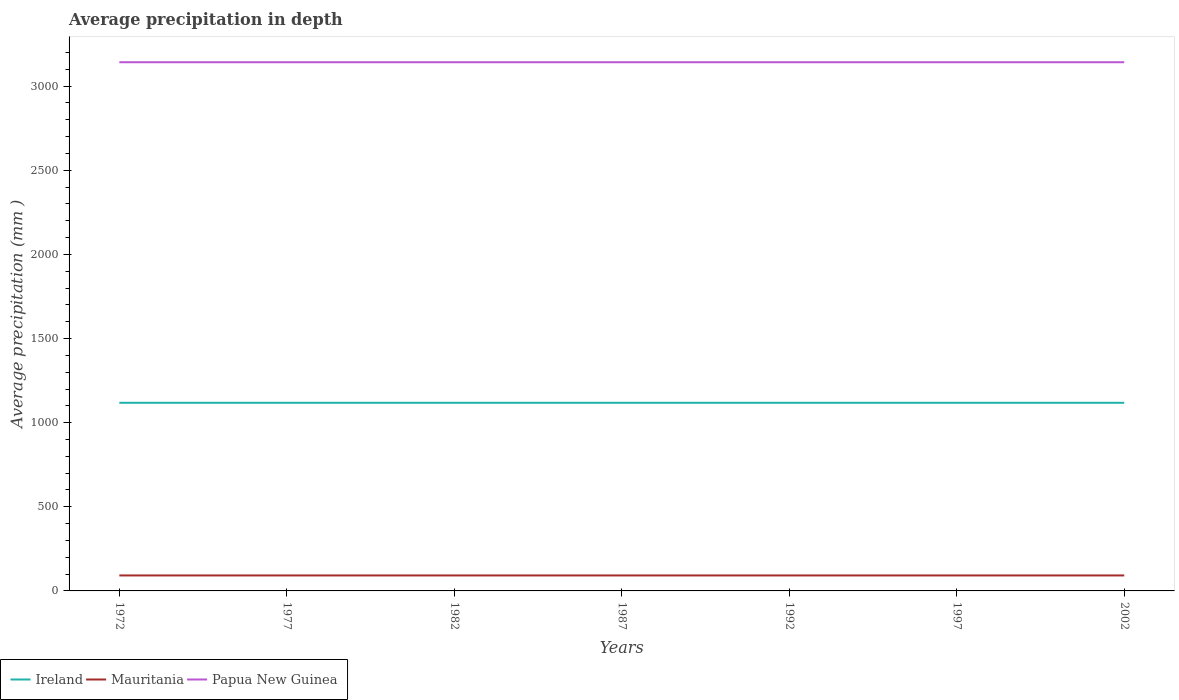How many different coloured lines are there?
Make the answer very short. 3. Does the line corresponding to Papua New Guinea intersect with the line corresponding to Ireland?
Make the answer very short. No. Is the number of lines equal to the number of legend labels?
Your answer should be compact. Yes. Across all years, what is the maximum average precipitation in Ireland?
Keep it short and to the point. 1118. In which year was the average precipitation in Ireland maximum?
Your answer should be compact. 1972. What is the total average precipitation in Mauritania in the graph?
Offer a terse response. 0. What is the difference between the highest and the second highest average precipitation in Ireland?
Offer a very short reply. 0. Is the average precipitation in Mauritania strictly greater than the average precipitation in Papua New Guinea over the years?
Provide a short and direct response. Yes. How many years are there in the graph?
Provide a succinct answer. 7. What is the difference between two consecutive major ticks on the Y-axis?
Provide a succinct answer. 500. Are the values on the major ticks of Y-axis written in scientific E-notation?
Offer a very short reply. No. Does the graph contain any zero values?
Your answer should be compact. No. Does the graph contain grids?
Your answer should be very brief. No. What is the title of the graph?
Provide a succinct answer. Average precipitation in depth. What is the label or title of the X-axis?
Offer a very short reply. Years. What is the label or title of the Y-axis?
Give a very brief answer. Average precipitation (mm ). What is the Average precipitation (mm ) in Ireland in 1972?
Your answer should be very brief. 1118. What is the Average precipitation (mm ) of Mauritania in 1972?
Give a very brief answer. 92. What is the Average precipitation (mm ) of Papua New Guinea in 1972?
Offer a terse response. 3142. What is the Average precipitation (mm ) of Ireland in 1977?
Your answer should be compact. 1118. What is the Average precipitation (mm ) in Mauritania in 1977?
Your response must be concise. 92. What is the Average precipitation (mm ) in Papua New Guinea in 1977?
Ensure brevity in your answer.  3142. What is the Average precipitation (mm ) of Ireland in 1982?
Ensure brevity in your answer.  1118. What is the Average precipitation (mm ) of Mauritania in 1982?
Make the answer very short. 92. What is the Average precipitation (mm ) in Papua New Guinea in 1982?
Your response must be concise. 3142. What is the Average precipitation (mm ) of Ireland in 1987?
Give a very brief answer. 1118. What is the Average precipitation (mm ) of Mauritania in 1987?
Your answer should be very brief. 92. What is the Average precipitation (mm ) of Papua New Guinea in 1987?
Make the answer very short. 3142. What is the Average precipitation (mm ) in Ireland in 1992?
Keep it short and to the point. 1118. What is the Average precipitation (mm ) in Mauritania in 1992?
Ensure brevity in your answer.  92. What is the Average precipitation (mm ) of Papua New Guinea in 1992?
Keep it short and to the point. 3142. What is the Average precipitation (mm ) of Ireland in 1997?
Give a very brief answer. 1118. What is the Average precipitation (mm ) in Mauritania in 1997?
Provide a short and direct response. 92. What is the Average precipitation (mm ) of Papua New Guinea in 1997?
Provide a succinct answer. 3142. What is the Average precipitation (mm ) of Ireland in 2002?
Your response must be concise. 1118. What is the Average precipitation (mm ) in Mauritania in 2002?
Keep it short and to the point. 92. What is the Average precipitation (mm ) of Papua New Guinea in 2002?
Provide a short and direct response. 3142. Across all years, what is the maximum Average precipitation (mm ) of Ireland?
Provide a short and direct response. 1118. Across all years, what is the maximum Average precipitation (mm ) in Mauritania?
Your answer should be very brief. 92. Across all years, what is the maximum Average precipitation (mm ) of Papua New Guinea?
Your answer should be compact. 3142. Across all years, what is the minimum Average precipitation (mm ) of Ireland?
Give a very brief answer. 1118. Across all years, what is the minimum Average precipitation (mm ) of Mauritania?
Make the answer very short. 92. Across all years, what is the minimum Average precipitation (mm ) in Papua New Guinea?
Your response must be concise. 3142. What is the total Average precipitation (mm ) of Ireland in the graph?
Offer a terse response. 7826. What is the total Average precipitation (mm ) of Mauritania in the graph?
Make the answer very short. 644. What is the total Average precipitation (mm ) in Papua New Guinea in the graph?
Provide a short and direct response. 2.20e+04. What is the difference between the Average precipitation (mm ) of Papua New Guinea in 1972 and that in 1977?
Keep it short and to the point. 0. What is the difference between the Average precipitation (mm ) of Papua New Guinea in 1972 and that in 1982?
Your answer should be compact. 0. What is the difference between the Average precipitation (mm ) in Ireland in 1972 and that in 2002?
Provide a short and direct response. 0. What is the difference between the Average precipitation (mm ) of Ireland in 1977 and that in 1982?
Give a very brief answer. 0. What is the difference between the Average precipitation (mm ) in Papua New Guinea in 1977 and that in 1982?
Offer a very short reply. 0. What is the difference between the Average precipitation (mm ) in Mauritania in 1977 and that in 1987?
Ensure brevity in your answer.  0. What is the difference between the Average precipitation (mm ) in Papua New Guinea in 1977 and that in 1987?
Give a very brief answer. 0. What is the difference between the Average precipitation (mm ) in Papua New Guinea in 1977 and that in 1992?
Your response must be concise. 0. What is the difference between the Average precipitation (mm ) in Papua New Guinea in 1977 and that in 1997?
Provide a succinct answer. 0. What is the difference between the Average precipitation (mm ) of Mauritania in 1982 and that in 1987?
Offer a very short reply. 0. What is the difference between the Average precipitation (mm ) in Ireland in 1982 and that in 1992?
Provide a succinct answer. 0. What is the difference between the Average precipitation (mm ) in Papua New Guinea in 1982 and that in 1992?
Give a very brief answer. 0. What is the difference between the Average precipitation (mm ) of Mauritania in 1982 and that in 1997?
Your answer should be very brief. 0. What is the difference between the Average precipitation (mm ) of Ireland in 1982 and that in 2002?
Your answer should be compact. 0. What is the difference between the Average precipitation (mm ) of Papua New Guinea in 1982 and that in 2002?
Make the answer very short. 0. What is the difference between the Average precipitation (mm ) of Ireland in 1987 and that in 1992?
Ensure brevity in your answer.  0. What is the difference between the Average precipitation (mm ) in Papua New Guinea in 1987 and that in 1997?
Your response must be concise. 0. What is the difference between the Average precipitation (mm ) of Ireland in 1987 and that in 2002?
Your answer should be compact. 0. What is the difference between the Average precipitation (mm ) of Ireland in 1992 and that in 1997?
Your answer should be very brief. 0. What is the difference between the Average precipitation (mm ) in Papua New Guinea in 1992 and that in 1997?
Offer a very short reply. 0. What is the difference between the Average precipitation (mm ) in Ireland in 1992 and that in 2002?
Make the answer very short. 0. What is the difference between the Average precipitation (mm ) in Mauritania in 1992 and that in 2002?
Provide a succinct answer. 0. What is the difference between the Average precipitation (mm ) in Mauritania in 1997 and that in 2002?
Keep it short and to the point. 0. What is the difference between the Average precipitation (mm ) in Papua New Guinea in 1997 and that in 2002?
Offer a terse response. 0. What is the difference between the Average precipitation (mm ) in Ireland in 1972 and the Average precipitation (mm ) in Mauritania in 1977?
Offer a terse response. 1026. What is the difference between the Average precipitation (mm ) of Ireland in 1972 and the Average precipitation (mm ) of Papua New Guinea in 1977?
Offer a very short reply. -2024. What is the difference between the Average precipitation (mm ) in Mauritania in 1972 and the Average precipitation (mm ) in Papua New Guinea in 1977?
Offer a terse response. -3050. What is the difference between the Average precipitation (mm ) of Ireland in 1972 and the Average precipitation (mm ) of Mauritania in 1982?
Keep it short and to the point. 1026. What is the difference between the Average precipitation (mm ) of Ireland in 1972 and the Average precipitation (mm ) of Papua New Guinea in 1982?
Give a very brief answer. -2024. What is the difference between the Average precipitation (mm ) in Mauritania in 1972 and the Average precipitation (mm ) in Papua New Guinea in 1982?
Your answer should be compact. -3050. What is the difference between the Average precipitation (mm ) in Ireland in 1972 and the Average precipitation (mm ) in Mauritania in 1987?
Offer a terse response. 1026. What is the difference between the Average precipitation (mm ) of Ireland in 1972 and the Average precipitation (mm ) of Papua New Guinea in 1987?
Offer a very short reply. -2024. What is the difference between the Average precipitation (mm ) of Mauritania in 1972 and the Average precipitation (mm ) of Papua New Guinea in 1987?
Provide a short and direct response. -3050. What is the difference between the Average precipitation (mm ) of Ireland in 1972 and the Average precipitation (mm ) of Mauritania in 1992?
Keep it short and to the point. 1026. What is the difference between the Average precipitation (mm ) of Ireland in 1972 and the Average precipitation (mm ) of Papua New Guinea in 1992?
Keep it short and to the point. -2024. What is the difference between the Average precipitation (mm ) of Mauritania in 1972 and the Average precipitation (mm ) of Papua New Guinea in 1992?
Keep it short and to the point. -3050. What is the difference between the Average precipitation (mm ) in Ireland in 1972 and the Average precipitation (mm ) in Mauritania in 1997?
Your response must be concise. 1026. What is the difference between the Average precipitation (mm ) of Ireland in 1972 and the Average precipitation (mm ) of Papua New Guinea in 1997?
Ensure brevity in your answer.  -2024. What is the difference between the Average precipitation (mm ) of Mauritania in 1972 and the Average precipitation (mm ) of Papua New Guinea in 1997?
Provide a short and direct response. -3050. What is the difference between the Average precipitation (mm ) of Ireland in 1972 and the Average precipitation (mm ) of Mauritania in 2002?
Offer a very short reply. 1026. What is the difference between the Average precipitation (mm ) of Ireland in 1972 and the Average precipitation (mm ) of Papua New Guinea in 2002?
Ensure brevity in your answer.  -2024. What is the difference between the Average precipitation (mm ) of Mauritania in 1972 and the Average precipitation (mm ) of Papua New Guinea in 2002?
Give a very brief answer. -3050. What is the difference between the Average precipitation (mm ) in Ireland in 1977 and the Average precipitation (mm ) in Mauritania in 1982?
Provide a short and direct response. 1026. What is the difference between the Average precipitation (mm ) of Ireland in 1977 and the Average precipitation (mm ) of Papua New Guinea in 1982?
Make the answer very short. -2024. What is the difference between the Average precipitation (mm ) of Mauritania in 1977 and the Average precipitation (mm ) of Papua New Guinea in 1982?
Provide a succinct answer. -3050. What is the difference between the Average precipitation (mm ) of Ireland in 1977 and the Average precipitation (mm ) of Mauritania in 1987?
Offer a very short reply. 1026. What is the difference between the Average precipitation (mm ) in Ireland in 1977 and the Average precipitation (mm ) in Papua New Guinea in 1987?
Give a very brief answer. -2024. What is the difference between the Average precipitation (mm ) in Mauritania in 1977 and the Average precipitation (mm ) in Papua New Guinea in 1987?
Make the answer very short. -3050. What is the difference between the Average precipitation (mm ) in Ireland in 1977 and the Average precipitation (mm ) in Mauritania in 1992?
Provide a short and direct response. 1026. What is the difference between the Average precipitation (mm ) of Ireland in 1977 and the Average precipitation (mm ) of Papua New Guinea in 1992?
Provide a short and direct response. -2024. What is the difference between the Average precipitation (mm ) of Mauritania in 1977 and the Average precipitation (mm ) of Papua New Guinea in 1992?
Your answer should be very brief. -3050. What is the difference between the Average precipitation (mm ) in Ireland in 1977 and the Average precipitation (mm ) in Mauritania in 1997?
Give a very brief answer. 1026. What is the difference between the Average precipitation (mm ) in Ireland in 1977 and the Average precipitation (mm ) in Papua New Guinea in 1997?
Provide a succinct answer. -2024. What is the difference between the Average precipitation (mm ) of Mauritania in 1977 and the Average precipitation (mm ) of Papua New Guinea in 1997?
Keep it short and to the point. -3050. What is the difference between the Average precipitation (mm ) in Ireland in 1977 and the Average precipitation (mm ) in Mauritania in 2002?
Provide a short and direct response. 1026. What is the difference between the Average precipitation (mm ) of Ireland in 1977 and the Average precipitation (mm ) of Papua New Guinea in 2002?
Keep it short and to the point. -2024. What is the difference between the Average precipitation (mm ) of Mauritania in 1977 and the Average precipitation (mm ) of Papua New Guinea in 2002?
Keep it short and to the point. -3050. What is the difference between the Average precipitation (mm ) in Ireland in 1982 and the Average precipitation (mm ) in Mauritania in 1987?
Your response must be concise. 1026. What is the difference between the Average precipitation (mm ) in Ireland in 1982 and the Average precipitation (mm ) in Papua New Guinea in 1987?
Keep it short and to the point. -2024. What is the difference between the Average precipitation (mm ) of Mauritania in 1982 and the Average precipitation (mm ) of Papua New Guinea in 1987?
Your answer should be very brief. -3050. What is the difference between the Average precipitation (mm ) in Ireland in 1982 and the Average precipitation (mm ) in Mauritania in 1992?
Give a very brief answer. 1026. What is the difference between the Average precipitation (mm ) in Ireland in 1982 and the Average precipitation (mm ) in Papua New Guinea in 1992?
Make the answer very short. -2024. What is the difference between the Average precipitation (mm ) in Mauritania in 1982 and the Average precipitation (mm ) in Papua New Guinea in 1992?
Provide a succinct answer. -3050. What is the difference between the Average precipitation (mm ) of Ireland in 1982 and the Average precipitation (mm ) of Mauritania in 1997?
Your response must be concise. 1026. What is the difference between the Average precipitation (mm ) of Ireland in 1982 and the Average precipitation (mm ) of Papua New Guinea in 1997?
Provide a short and direct response. -2024. What is the difference between the Average precipitation (mm ) in Mauritania in 1982 and the Average precipitation (mm ) in Papua New Guinea in 1997?
Keep it short and to the point. -3050. What is the difference between the Average precipitation (mm ) of Ireland in 1982 and the Average precipitation (mm ) of Mauritania in 2002?
Ensure brevity in your answer.  1026. What is the difference between the Average precipitation (mm ) of Ireland in 1982 and the Average precipitation (mm ) of Papua New Guinea in 2002?
Your answer should be compact. -2024. What is the difference between the Average precipitation (mm ) in Mauritania in 1982 and the Average precipitation (mm ) in Papua New Guinea in 2002?
Provide a short and direct response. -3050. What is the difference between the Average precipitation (mm ) in Ireland in 1987 and the Average precipitation (mm ) in Mauritania in 1992?
Make the answer very short. 1026. What is the difference between the Average precipitation (mm ) in Ireland in 1987 and the Average precipitation (mm ) in Papua New Guinea in 1992?
Your answer should be compact. -2024. What is the difference between the Average precipitation (mm ) in Mauritania in 1987 and the Average precipitation (mm ) in Papua New Guinea in 1992?
Keep it short and to the point. -3050. What is the difference between the Average precipitation (mm ) in Ireland in 1987 and the Average precipitation (mm ) in Mauritania in 1997?
Offer a very short reply. 1026. What is the difference between the Average precipitation (mm ) in Ireland in 1987 and the Average precipitation (mm ) in Papua New Guinea in 1997?
Your answer should be very brief. -2024. What is the difference between the Average precipitation (mm ) of Mauritania in 1987 and the Average precipitation (mm ) of Papua New Guinea in 1997?
Make the answer very short. -3050. What is the difference between the Average precipitation (mm ) of Ireland in 1987 and the Average precipitation (mm ) of Mauritania in 2002?
Ensure brevity in your answer.  1026. What is the difference between the Average precipitation (mm ) of Ireland in 1987 and the Average precipitation (mm ) of Papua New Guinea in 2002?
Provide a short and direct response. -2024. What is the difference between the Average precipitation (mm ) of Mauritania in 1987 and the Average precipitation (mm ) of Papua New Guinea in 2002?
Give a very brief answer. -3050. What is the difference between the Average precipitation (mm ) in Ireland in 1992 and the Average precipitation (mm ) in Mauritania in 1997?
Offer a terse response. 1026. What is the difference between the Average precipitation (mm ) in Ireland in 1992 and the Average precipitation (mm ) in Papua New Guinea in 1997?
Your answer should be compact. -2024. What is the difference between the Average precipitation (mm ) in Mauritania in 1992 and the Average precipitation (mm ) in Papua New Guinea in 1997?
Your answer should be very brief. -3050. What is the difference between the Average precipitation (mm ) in Ireland in 1992 and the Average precipitation (mm ) in Mauritania in 2002?
Keep it short and to the point. 1026. What is the difference between the Average precipitation (mm ) of Ireland in 1992 and the Average precipitation (mm ) of Papua New Guinea in 2002?
Make the answer very short. -2024. What is the difference between the Average precipitation (mm ) in Mauritania in 1992 and the Average precipitation (mm ) in Papua New Guinea in 2002?
Ensure brevity in your answer.  -3050. What is the difference between the Average precipitation (mm ) of Ireland in 1997 and the Average precipitation (mm ) of Mauritania in 2002?
Make the answer very short. 1026. What is the difference between the Average precipitation (mm ) of Ireland in 1997 and the Average precipitation (mm ) of Papua New Guinea in 2002?
Provide a succinct answer. -2024. What is the difference between the Average precipitation (mm ) in Mauritania in 1997 and the Average precipitation (mm ) in Papua New Guinea in 2002?
Your answer should be compact. -3050. What is the average Average precipitation (mm ) in Ireland per year?
Your answer should be compact. 1118. What is the average Average precipitation (mm ) in Mauritania per year?
Provide a succinct answer. 92. What is the average Average precipitation (mm ) in Papua New Guinea per year?
Give a very brief answer. 3142. In the year 1972, what is the difference between the Average precipitation (mm ) in Ireland and Average precipitation (mm ) in Mauritania?
Offer a terse response. 1026. In the year 1972, what is the difference between the Average precipitation (mm ) of Ireland and Average precipitation (mm ) of Papua New Guinea?
Give a very brief answer. -2024. In the year 1972, what is the difference between the Average precipitation (mm ) in Mauritania and Average precipitation (mm ) in Papua New Guinea?
Your response must be concise. -3050. In the year 1977, what is the difference between the Average precipitation (mm ) of Ireland and Average precipitation (mm ) of Mauritania?
Offer a terse response. 1026. In the year 1977, what is the difference between the Average precipitation (mm ) in Ireland and Average precipitation (mm ) in Papua New Guinea?
Your response must be concise. -2024. In the year 1977, what is the difference between the Average precipitation (mm ) in Mauritania and Average precipitation (mm ) in Papua New Guinea?
Offer a terse response. -3050. In the year 1982, what is the difference between the Average precipitation (mm ) in Ireland and Average precipitation (mm ) in Mauritania?
Ensure brevity in your answer.  1026. In the year 1982, what is the difference between the Average precipitation (mm ) of Ireland and Average precipitation (mm ) of Papua New Guinea?
Offer a terse response. -2024. In the year 1982, what is the difference between the Average precipitation (mm ) in Mauritania and Average precipitation (mm ) in Papua New Guinea?
Offer a terse response. -3050. In the year 1987, what is the difference between the Average precipitation (mm ) in Ireland and Average precipitation (mm ) in Mauritania?
Your answer should be very brief. 1026. In the year 1987, what is the difference between the Average precipitation (mm ) of Ireland and Average precipitation (mm ) of Papua New Guinea?
Keep it short and to the point. -2024. In the year 1987, what is the difference between the Average precipitation (mm ) in Mauritania and Average precipitation (mm ) in Papua New Guinea?
Offer a terse response. -3050. In the year 1992, what is the difference between the Average precipitation (mm ) of Ireland and Average precipitation (mm ) of Mauritania?
Ensure brevity in your answer.  1026. In the year 1992, what is the difference between the Average precipitation (mm ) in Ireland and Average precipitation (mm ) in Papua New Guinea?
Ensure brevity in your answer.  -2024. In the year 1992, what is the difference between the Average precipitation (mm ) in Mauritania and Average precipitation (mm ) in Papua New Guinea?
Keep it short and to the point. -3050. In the year 1997, what is the difference between the Average precipitation (mm ) of Ireland and Average precipitation (mm ) of Mauritania?
Your response must be concise. 1026. In the year 1997, what is the difference between the Average precipitation (mm ) in Ireland and Average precipitation (mm ) in Papua New Guinea?
Make the answer very short. -2024. In the year 1997, what is the difference between the Average precipitation (mm ) of Mauritania and Average precipitation (mm ) of Papua New Guinea?
Ensure brevity in your answer.  -3050. In the year 2002, what is the difference between the Average precipitation (mm ) of Ireland and Average precipitation (mm ) of Mauritania?
Your answer should be compact. 1026. In the year 2002, what is the difference between the Average precipitation (mm ) in Ireland and Average precipitation (mm ) in Papua New Guinea?
Your answer should be very brief. -2024. In the year 2002, what is the difference between the Average precipitation (mm ) of Mauritania and Average precipitation (mm ) of Papua New Guinea?
Give a very brief answer. -3050. What is the ratio of the Average precipitation (mm ) in Ireland in 1972 to that in 1982?
Make the answer very short. 1. What is the ratio of the Average precipitation (mm ) of Papua New Guinea in 1972 to that in 1982?
Provide a short and direct response. 1. What is the ratio of the Average precipitation (mm ) in Mauritania in 1972 to that in 1987?
Give a very brief answer. 1. What is the ratio of the Average precipitation (mm ) in Papua New Guinea in 1972 to that in 1987?
Your answer should be compact. 1. What is the ratio of the Average precipitation (mm ) of Ireland in 1972 to that in 1992?
Your response must be concise. 1. What is the ratio of the Average precipitation (mm ) in Mauritania in 1972 to that in 1992?
Make the answer very short. 1. What is the ratio of the Average precipitation (mm ) of Papua New Guinea in 1972 to that in 1992?
Make the answer very short. 1. What is the ratio of the Average precipitation (mm ) in Ireland in 1972 to that in 1997?
Make the answer very short. 1. What is the ratio of the Average precipitation (mm ) of Papua New Guinea in 1972 to that in 1997?
Make the answer very short. 1. What is the ratio of the Average precipitation (mm ) in Ireland in 1972 to that in 2002?
Offer a very short reply. 1. What is the ratio of the Average precipitation (mm ) in Mauritania in 1972 to that in 2002?
Make the answer very short. 1. What is the ratio of the Average precipitation (mm ) of Papua New Guinea in 1972 to that in 2002?
Provide a short and direct response. 1. What is the ratio of the Average precipitation (mm ) of Mauritania in 1977 to that in 1982?
Make the answer very short. 1. What is the ratio of the Average precipitation (mm ) in Papua New Guinea in 1977 to that in 1982?
Provide a short and direct response. 1. What is the ratio of the Average precipitation (mm ) in Ireland in 1977 to that in 1987?
Your response must be concise. 1. What is the ratio of the Average precipitation (mm ) in Papua New Guinea in 1977 to that in 1992?
Offer a terse response. 1. What is the ratio of the Average precipitation (mm ) in Ireland in 1977 to that in 1997?
Provide a short and direct response. 1. What is the ratio of the Average precipitation (mm ) in Mauritania in 1977 to that in 1997?
Keep it short and to the point. 1. What is the ratio of the Average precipitation (mm ) in Papua New Guinea in 1977 to that in 1997?
Provide a short and direct response. 1. What is the ratio of the Average precipitation (mm ) of Ireland in 1977 to that in 2002?
Provide a succinct answer. 1. What is the ratio of the Average precipitation (mm ) in Mauritania in 1977 to that in 2002?
Your answer should be compact. 1. What is the ratio of the Average precipitation (mm ) in Papua New Guinea in 1977 to that in 2002?
Your response must be concise. 1. What is the ratio of the Average precipitation (mm ) of Ireland in 1982 to that in 1987?
Make the answer very short. 1. What is the ratio of the Average precipitation (mm ) in Mauritania in 1982 to that in 1987?
Make the answer very short. 1. What is the ratio of the Average precipitation (mm ) in Papua New Guinea in 1982 to that in 1987?
Give a very brief answer. 1. What is the ratio of the Average precipitation (mm ) of Papua New Guinea in 1982 to that in 1992?
Your answer should be compact. 1. What is the ratio of the Average precipitation (mm ) in Mauritania in 1982 to that in 1997?
Your answer should be very brief. 1. What is the ratio of the Average precipitation (mm ) of Papua New Guinea in 1982 to that in 1997?
Offer a terse response. 1. What is the ratio of the Average precipitation (mm ) of Mauritania in 1982 to that in 2002?
Give a very brief answer. 1. What is the ratio of the Average precipitation (mm ) in Mauritania in 1987 to that in 1992?
Your answer should be compact. 1. What is the ratio of the Average precipitation (mm ) of Papua New Guinea in 1987 to that in 1992?
Keep it short and to the point. 1. What is the ratio of the Average precipitation (mm ) of Ireland in 1987 to that in 2002?
Offer a very short reply. 1. What is the ratio of the Average precipitation (mm ) of Mauritania in 1992 to that in 1997?
Make the answer very short. 1. What is the ratio of the Average precipitation (mm ) in Papua New Guinea in 1992 to that in 1997?
Ensure brevity in your answer.  1. What is the ratio of the Average precipitation (mm ) in Mauritania in 1992 to that in 2002?
Your response must be concise. 1. What is the ratio of the Average precipitation (mm ) of Papua New Guinea in 1992 to that in 2002?
Give a very brief answer. 1. What is the ratio of the Average precipitation (mm ) of Ireland in 1997 to that in 2002?
Make the answer very short. 1. What is the ratio of the Average precipitation (mm ) of Mauritania in 1997 to that in 2002?
Offer a very short reply. 1. What is the ratio of the Average precipitation (mm ) of Papua New Guinea in 1997 to that in 2002?
Offer a very short reply. 1. What is the difference between the highest and the second highest Average precipitation (mm ) of Ireland?
Provide a succinct answer. 0. What is the difference between the highest and the second highest Average precipitation (mm ) of Papua New Guinea?
Your answer should be compact. 0. What is the difference between the highest and the lowest Average precipitation (mm ) of Ireland?
Offer a terse response. 0. What is the difference between the highest and the lowest Average precipitation (mm ) of Papua New Guinea?
Make the answer very short. 0. 